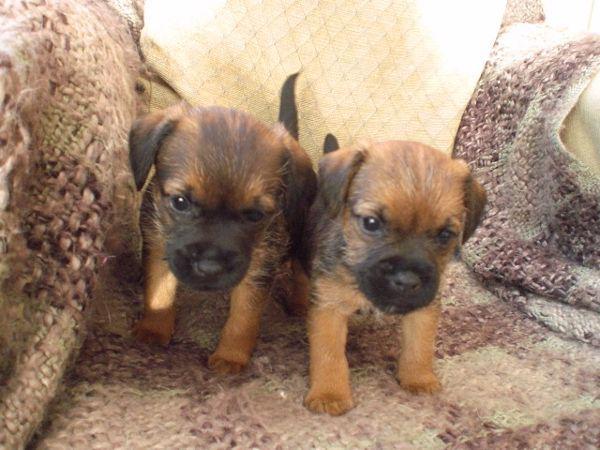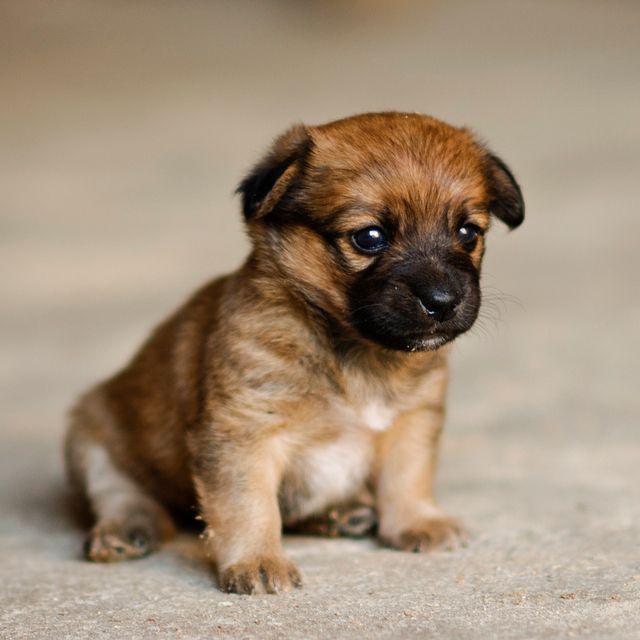The first image is the image on the left, the second image is the image on the right. For the images displayed, is the sentence "There are two dogs" factually correct? Answer yes or no. No. The first image is the image on the left, the second image is the image on the right. Considering the images on both sides, is "All of the images contain only one dog." valid? Answer yes or no. No. 